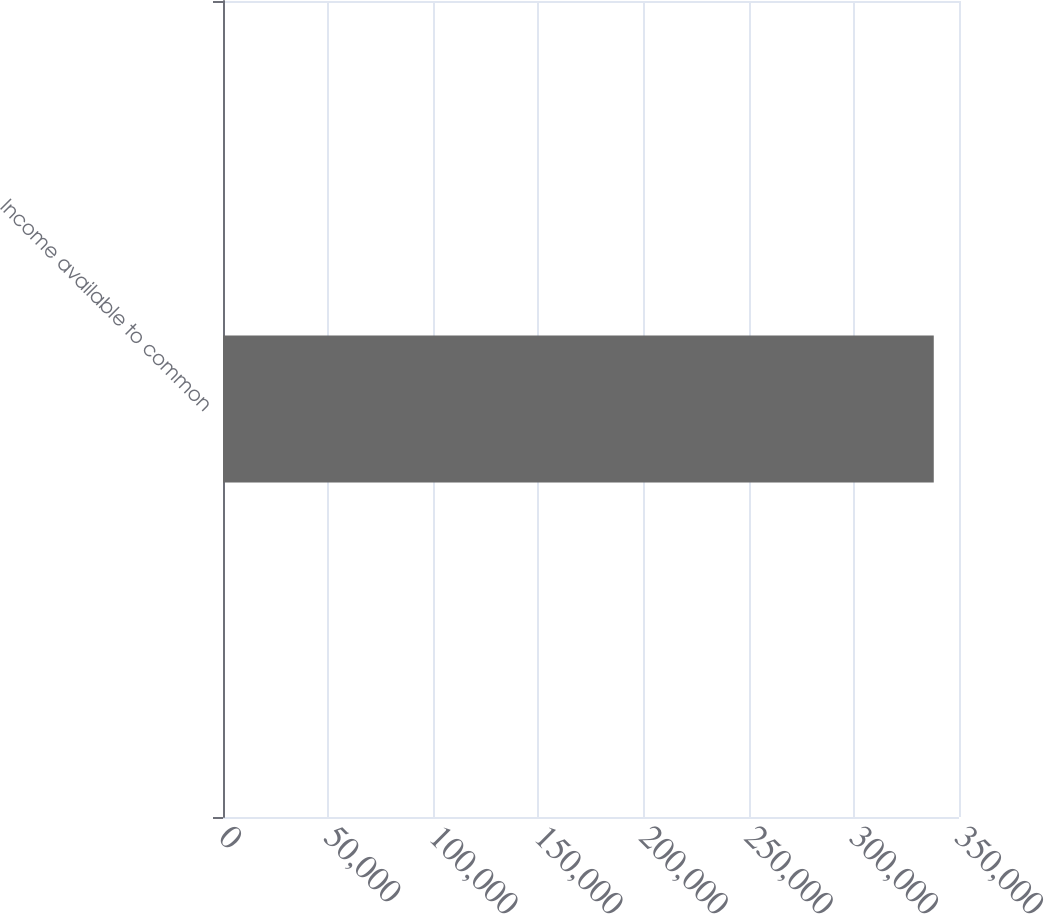<chart> <loc_0><loc_0><loc_500><loc_500><bar_chart><fcel>Income available to common<nl><fcel>337999<nl></chart> 